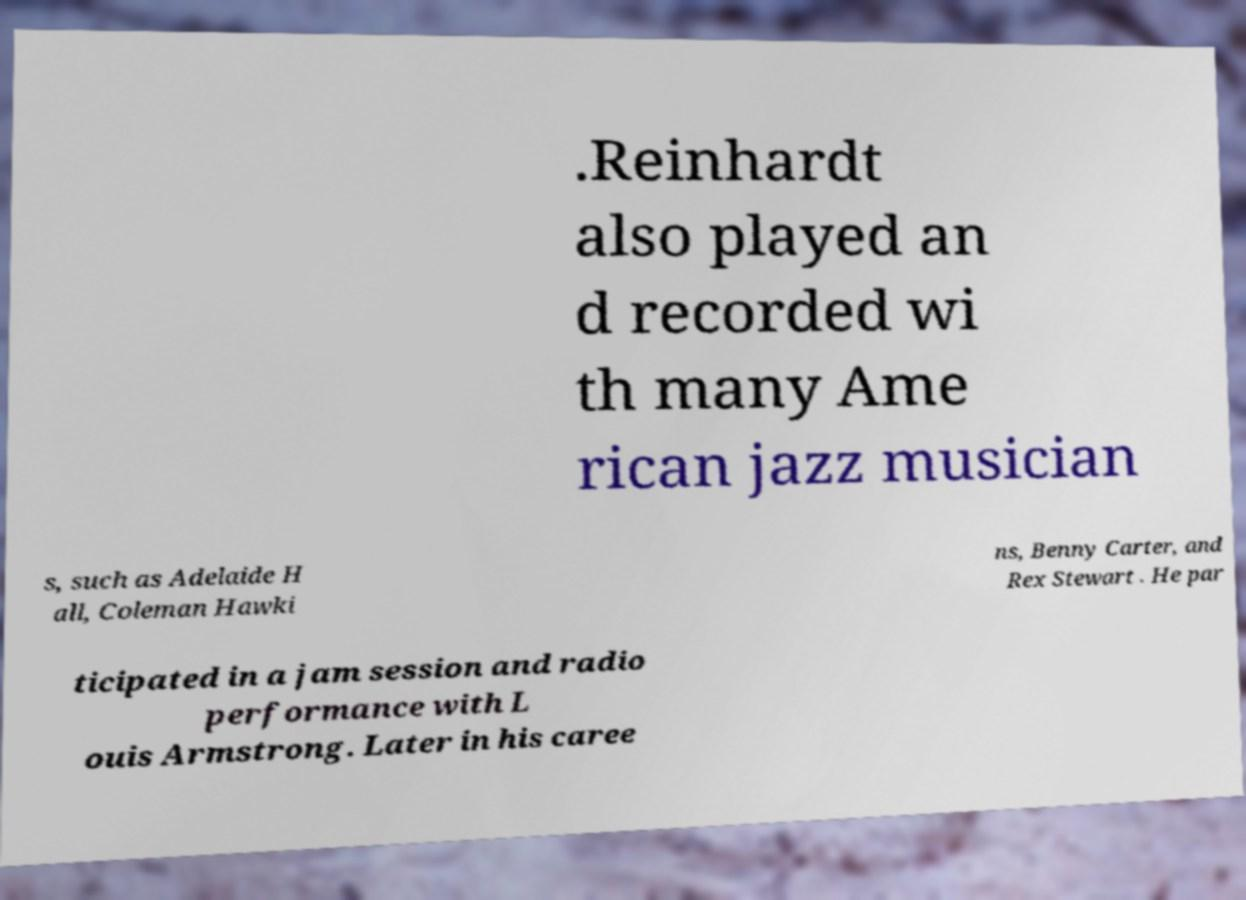Please identify and transcribe the text found in this image. .Reinhardt also played an d recorded wi th many Ame rican jazz musician s, such as Adelaide H all, Coleman Hawki ns, Benny Carter, and Rex Stewart . He par ticipated in a jam session and radio performance with L ouis Armstrong. Later in his caree 